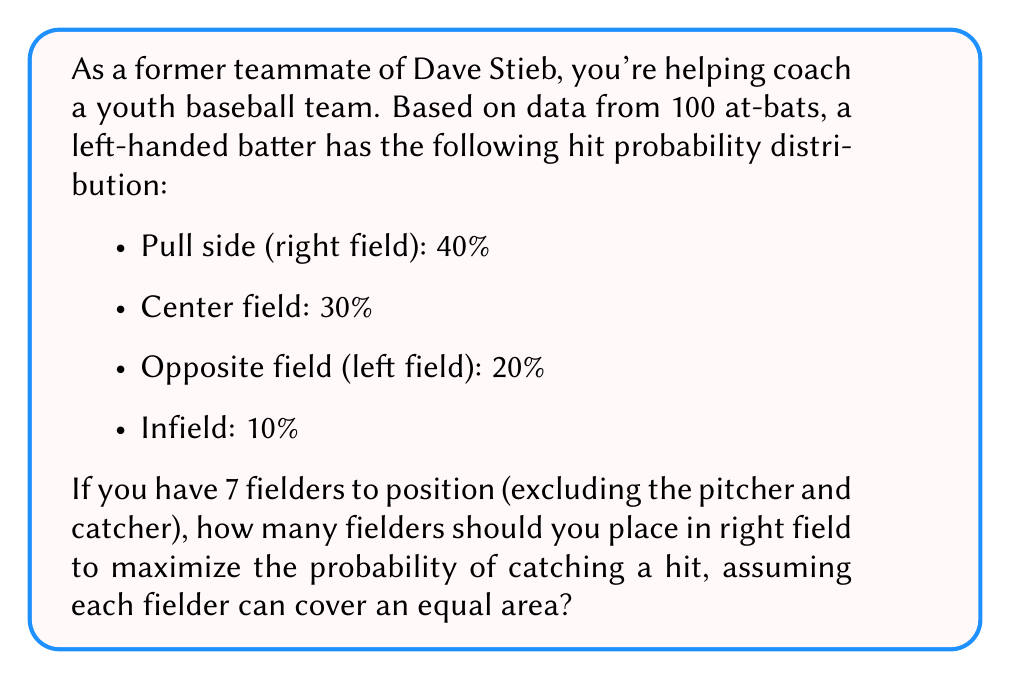Teach me how to tackle this problem. Let's approach this step-by-step:

1) First, we need to calculate the probability of a hit going to each fielder if they were evenly distributed:
   $P(\text{hit to each fielder}) = \frac{1}{7} \approx 14.29\%$

2) Now, let's compare this to the given probabilities:
   - Right field: 40% > 14.29%
   - Center field: 30% > 14.29%
   - Left field: 20% > 14.29%
   - Infield: 10% < 14.29%

3) We want to maximize the probability of catching a hit, so we should place fielders where the hit probability exceeds the average fielder coverage.

4) To calculate how many fielders should be in right field:
   $\text{Number of fielders} = \frac{\text{Right field probability}}{\text{Average fielder coverage}}$
   $= \frac{40\%}{14.29\%} \approx 2.80$

5) Since we can't have a fractional number of fielders, we round down to 2 fielders in right field.

6) This leaves 5 fielders for the rest of the field, which aligns with typical baseball strategy (2 outfielders, 4 infielders).
Answer: 2 fielders 